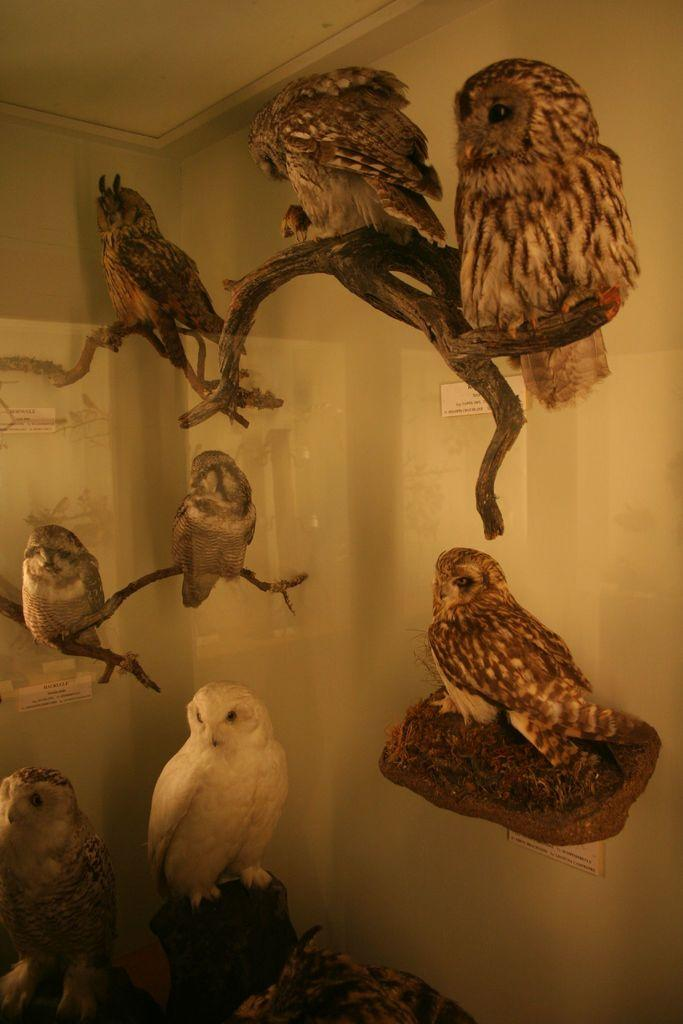What animals are present in the image? There are owls in the picture. How are the owls arranged or displayed in the image? The owls are placed in a glass container. Can you describe the variety of owls in the image? The owls are of different types. What type of snow can be seen falling in the image? There is no snow present in the image; it features owls in a glass container. 